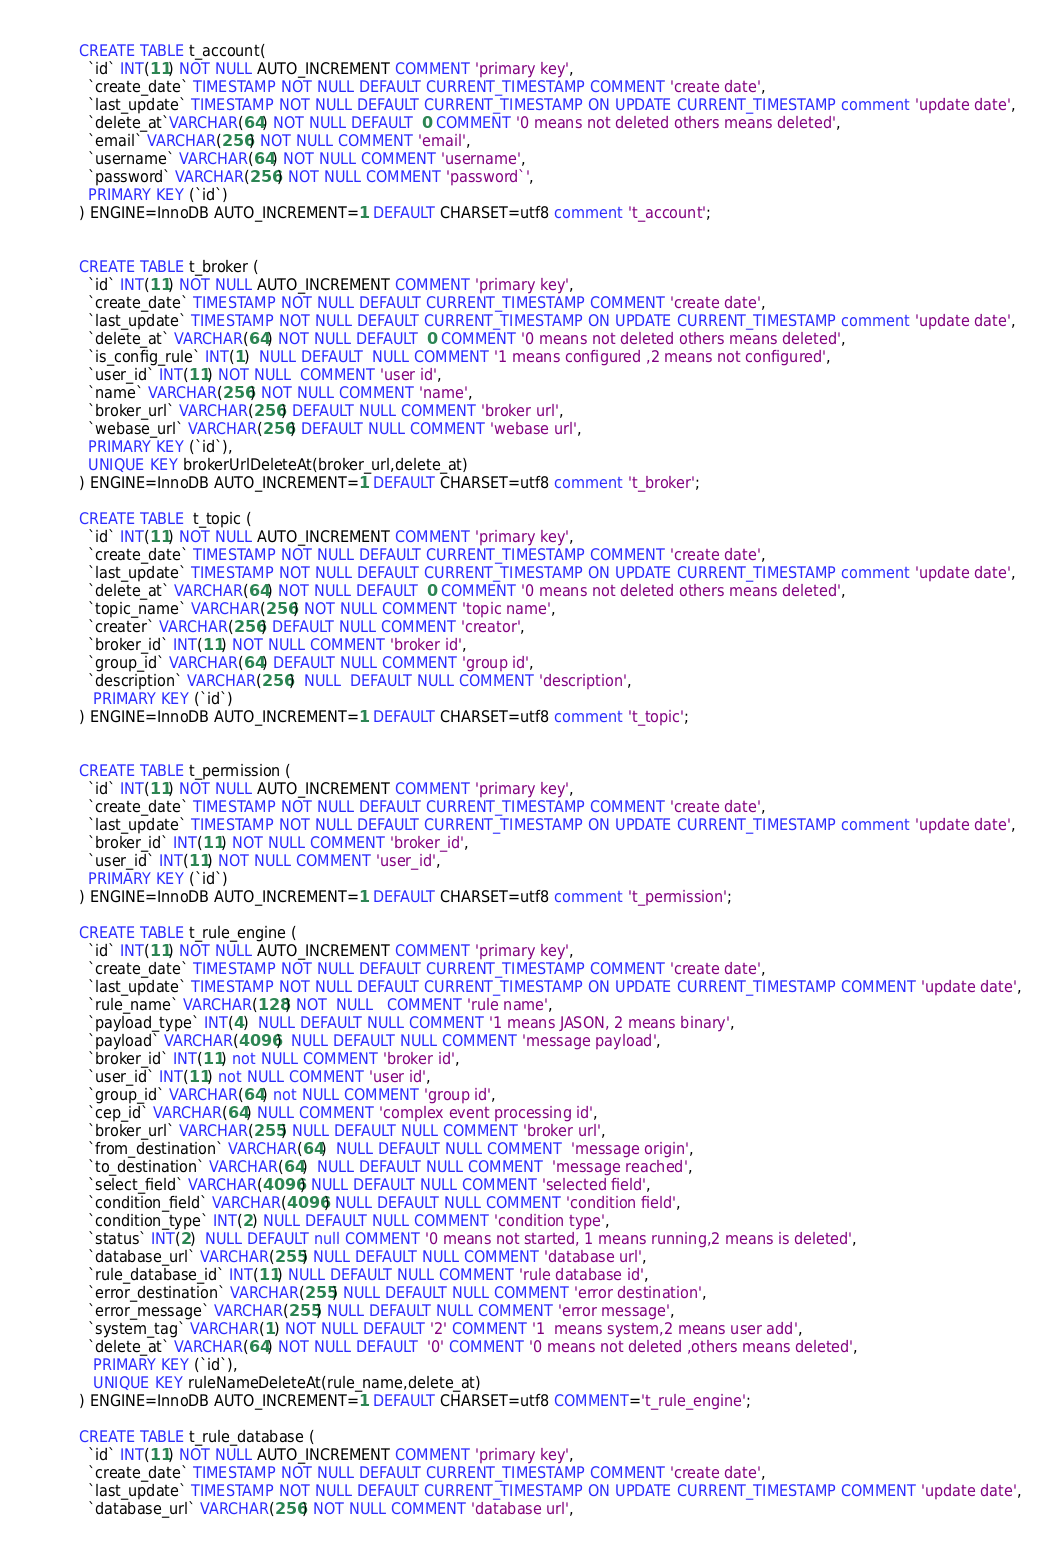Convert code to text. <code><loc_0><loc_0><loc_500><loc_500><_SQL_>CREATE TABLE t_account(
  `id` INT(11) NOT NULL AUTO_INCREMENT COMMENT 'primary key',
  `create_date` TIMESTAMP NOT NULL DEFAULT CURRENT_TIMESTAMP COMMENT 'create date',
  `last_update` TIMESTAMP NOT NULL DEFAULT CURRENT_TIMESTAMP ON UPDATE CURRENT_TIMESTAMP comment 'update date',
  `delete_at`VARCHAR(64) NOT NULL DEFAULT  0 COMMENT '0 means not deleted others means deleted',
  `email` VARCHAR(256) NOT NULL COMMENT 'email',
  `username` VARCHAR(64) NOT NULL COMMENT 'username',
  `password` VARCHAR(256) NOT NULL COMMENT 'password`',
  PRIMARY KEY (`id`)
) ENGINE=InnoDB AUTO_INCREMENT=1 DEFAULT CHARSET=utf8 comment 't_account';


CREATE TABLE t_broker (
  `id` INT(11) NOT NULL AUTO_INCREMENT COMMENT 'primary key',
  `create_date` TIMESTAMP NOT NULL DEFAULT CURRENT_TIMESTAMP COMMENT 'create date',
  `last_update` TIMESTAMP NOT NULL DEFAULT CURRENT_TIMESTAMP ON UPDATE CURRENT_TIMESTAMP comment 'update date',
  `delete_at` VARCHAR(64) NOT NULL DEFAULT  0 COMMENT '0 means not deleted others means deleted',
  `is_config_rule` INT(1)  NULL DEFAULT  NULL COMMENT '1 means configured ,2 means not configured',
  `user_id` INT(11) NOT NULL  COMMENT 'user id',
  `name` VARCHAR(256) NOT NULL COMMENT 'name',
  `broker_url` VARCHAR(256) DEFAULT NULL COMMENT 'broker url',
  `webase_url` VARCHAR(256) DEFAULT NULL COMMENT 'webase url',
  PRIMARY KEY (`id`),
  UNIQUE KEY brokerUrlDeleteAt(broker_url,delete_at)
) ENGINE=InnoDB AUTO_INCREMENT=1 DEFAULT CHARSET=utf8 comment 't_broker';

CREATE TABLE  t_topic (
  `id` INT(11) NOT NULL AUTO_INCREMENT COMMENT 'primary key',
  `create_date` TIMESTAMP NOT NULL DEFAULT CURRENT_TIMESTAMP COMMENT 'create date',
  `last_update` TIMESTAMP NOT NULL DEFAULT CURRENT_TIMESTAMP ON UPDATE CURRENT_TIMESTAMP comment 'update date',
  `delete_at` VARCHAR(64) NOT NULL DEFAULT  0 COMMENT '0 means not deleted others means deleted',
  `topic_name` VARCHAR(256) NOT NULL COMMENT 'topic name',
  `creater` VARCHAR(256) DEFAULT NULL COMMENT 'creator',
  `broker_id` INT(11) NOT NULL COMMENT 'broker id',
  `group_id` VARCHAR(64) DEFAULT NULL COMMENT 'group id',
  `description` VARCHAR(256)  NULL  DEFAULT NULL COMMENT 'description',
   PRIMARY KEY (`id`)
) ENGINE=InnoDB AUTO_INCREMENT=1 DEFAULT CHARSET=utf8 comment 't_topic';


CREATE TABLE t_permission (
  `id` INT(11) NOT NULL AUTO_INCREMENT COMMENT 'primary key',
  `create_date` TIMESTAMP NOT NULL DEFAULT CURRENT_TIMESTAMP COMMENT 'create date',
  `last_update` TIMESTAMP NOT NULL DEFAULT CURRENT_TIMESTAMP ON UPDATE CURRENT_TIMESTAMP comment 'update date',
  `broker_id` INT(11) NOT NULL COMMENT 'broker_id',
  `user_id` INT(11) NOT NULL COMMENT 'user_id',
  PRIMARY KEY (`id`)
) ENGINE=InnoDB AUTO_INCREMENT=1 DEFAULT CHARSET=utf8 comment 't_permission';

CREATE TABLE t_rule_engine (
  `id` INT(11) NOT NULL AUTO_INCREMENT COMMENT 'primary key',
  `create_date` TIMESTAMP NOT NULL DEFAULT CURRENT_TIMESTAMP COMMENT 'create date',
  `last_update` TIMESTAMP NOT NULL DEFAULT CURRENT_TIMESTAMP ON UPDATE CURRENT_TIMESTAMP COMMENT 'update date',
  `rule_name` VARCHAR(128) NOT  NULL   COMMENT 'rule name',
  `payload_type` INT(4)  NULL DEFAULT NULL COMMENT '1 means JASON, 2 means binary',
  `payload` VARCHAR(4096)  NULL DEFAULT NULL COMMENT 'message payload',
  `broker_id` INT(11) not NULL COMMENT 'broker id',
  `user_id` INT(11) not NULL COMMENT 'user id',
  `group_id` VARCHAR(64) not NULL COMMENT 'group id',
  `cep_id` VARCHAR(64) NULL COMMENT 'complex event processing id',
  `broker_url` VARCHAR(255) NULL DEFAULT NULL COMMENT 'broker url',
  `from_destination` VARCHAR(64)  NULL DEFAULT NULL COMMENT  'message origin',
  `to_destination` VARCHAR(64)  NULL DEFAULT NULL COMMENT  'message reached',
  `select_field` VARCHAR(4096) NULL DEFAULT NULL COMMENT 'selected field',
  `condition_field` VARCHAR(4096) NULL DEFAULT NULL COMMENT 'condition field',
  `condition_type` INT(2) NULL DEFAULT NULL COMMENT 'condition type',
  `status` INT(2)  NULL DEFAULT null COMMENT '0 means not started, 1 means running,2 means is deleted',
  `database_url` VARCHAR(255) NULL DEFAULT NULL COMMENT 'database url',
  `rule_database_id` INT(11) NULL DEFAULT NULL COMMENT 'rule database id',
  `error_destination` VARCHAR(255) NULL DEFAULT NULL COMMENT 'error destination',
  `error_message` VARCHAR(255) NULL DEFAULT NULL COMMENT 'error message',
  `system_tag` VARCHAR(1) NOT NULL DEFAULT '2' COMMENT '1  means system,2 means user add',
  `delete_at` VARCHAR(64) NOT NULL DEFAULT  '0' COMMENT '0 means not deleted ,others means deleted',
   PRIMARY KEY (`id`),
   UNIQUE KEY ruleNameDeleteAt(rule_name,delete_at)
) ENGINE=InnoDB AUTO_INCREMENT=1 DEFAULT CHARSET=utf8 COMMENT='t_rule_engine';

CREATE TABLE t_rule_database (
  `id` INT(11) NOT NULL AUTO_INCREMENT COMMENT 'primary key',
  `create_date` TIMESTAMP NOT NULL DEFAULT CURRENT_TIMESTAMP COMMENT 'create date',
  `last_update` TIMESTAMP NOT NULL DEFAULT CURRENT_TIMESTAMP ON UPDATE CURRENT_TIMESTAMP COMMENT 'update date',
  `database_url` VARCHAR(256) NOT NULL COMMENT 'database url',</code> 